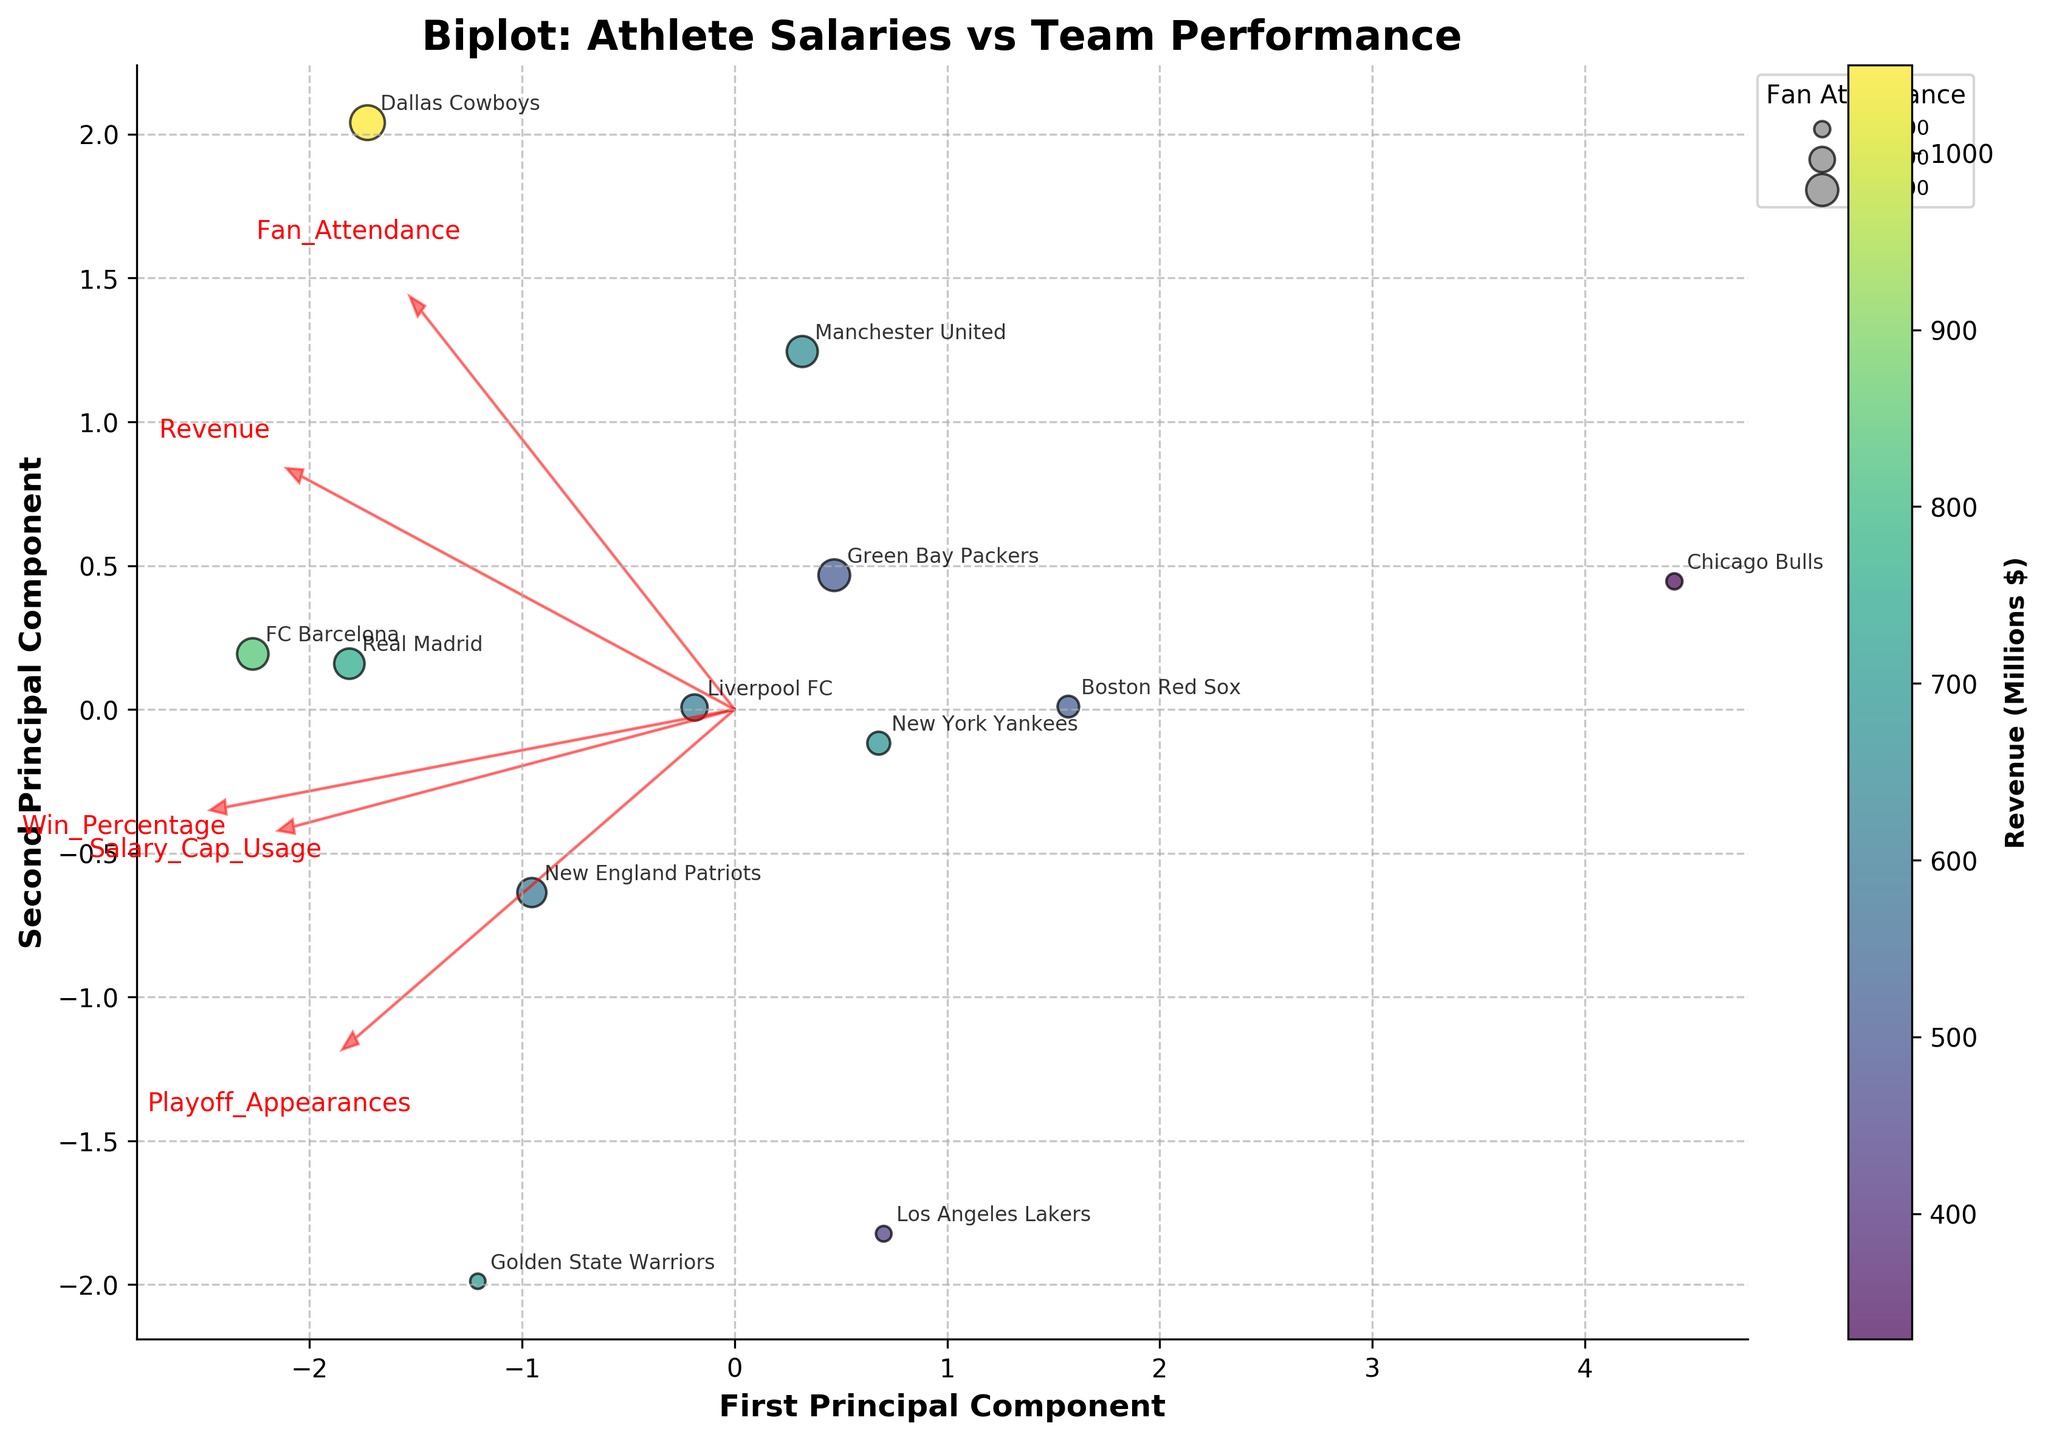What's the title of the figure? The title is displayed at the top of the figure and provides insight into the main topic of the plot. The title helps viewers quickly understand what the plot is about without needing to interpret further details first.
Answer: Biplot: Athlete Salaries vs Team Performance How many data points are represented in the plot? Count the number of distinct points scattered on the plot. Each point corresponds to a row in the dataset representing a team.
Answer: 12 Which principal component explains more variance in the data, the first or the second? The eigenvalues of the principal components, derived during PCA, determine the variance explained. The first principal component has a larger eigenvalue and hence explains more variance.
Answer: First principal component Which team has the highest revenue, and how is this represented in the plot? Sort the teams by revenue and identify the one with the highest value. This is represented by the color of the data points - the highest revenue corresponds to the lightest color on the color scale (viridis colormap).
Answer: Dallas Cowboys How is fan attendance visualized in the plot? Fan attendance is represented by the size of the data points. Larger attendance is shown with larger points. There's also a legend on the upper left showing bubble size corresponding to attendance values.
Answer: Size of data points Which teams have the closest proximity on the plot, and what does this suggest? Look for data points that are near each other in the plot. Closely located points imply that those teams have similar scores on the first and second principal components.
Answer: Los Angeles Lakers and Golden State Warriors How does the direction of the 'Win Percentage' vector relate to the data points? The direction and length of the vector indicate the influence of this variable on the principal components. Points in the direction of the 'Win Percentage' vector tend to have higher win percentages.
Answer: Positive relationship with Win Percentage Which variable appears to have the strongest influence on the first principal component? Observe the length and direction of the vectors from the origin. The variable with the largest projection on the first principal component axis is the one with the strongest influence.
Answer: Salary_Cap_Usage Is there a clear trend between salary cap usage and playoff appearances in the plot? Analyze the direction of these vectors and the positioning of data points. Similar directions suggest a positive trend, whereas opposite directions suggest a negative trend.
Answer: Yes, positive trend Which team has the lowest win percentage and how is it represented in the plot? Identify the team with the lowest win percentage from the dataset and locate its corresponding point. The position of the point in relation to the 'Win Percentage' vector can help confirm this.
Answer: Chicago Bulls 